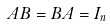<formula> <loc_0><loc_0><loc_500><loc_500>A B = B A = I _ { n }</formula> 